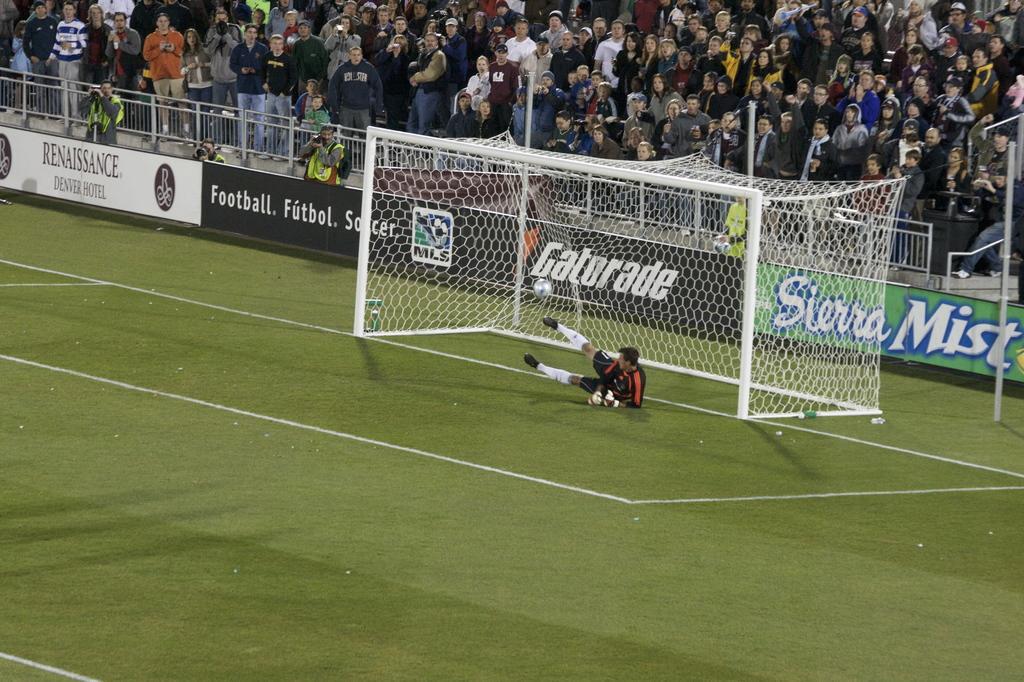Please provide a concise description of this image. In this image I see the pitch and I see a goal post and I see a man who is wearing jersey and I see the ball over here. In the background I see the fencing and boards on which there are words written and I see the logos and I see number of people and I see a pole over here. 